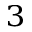Convert formula to latex. <formula><loc_0><loc_0><loc_500><loc_500>^ { 3 }</formula> 